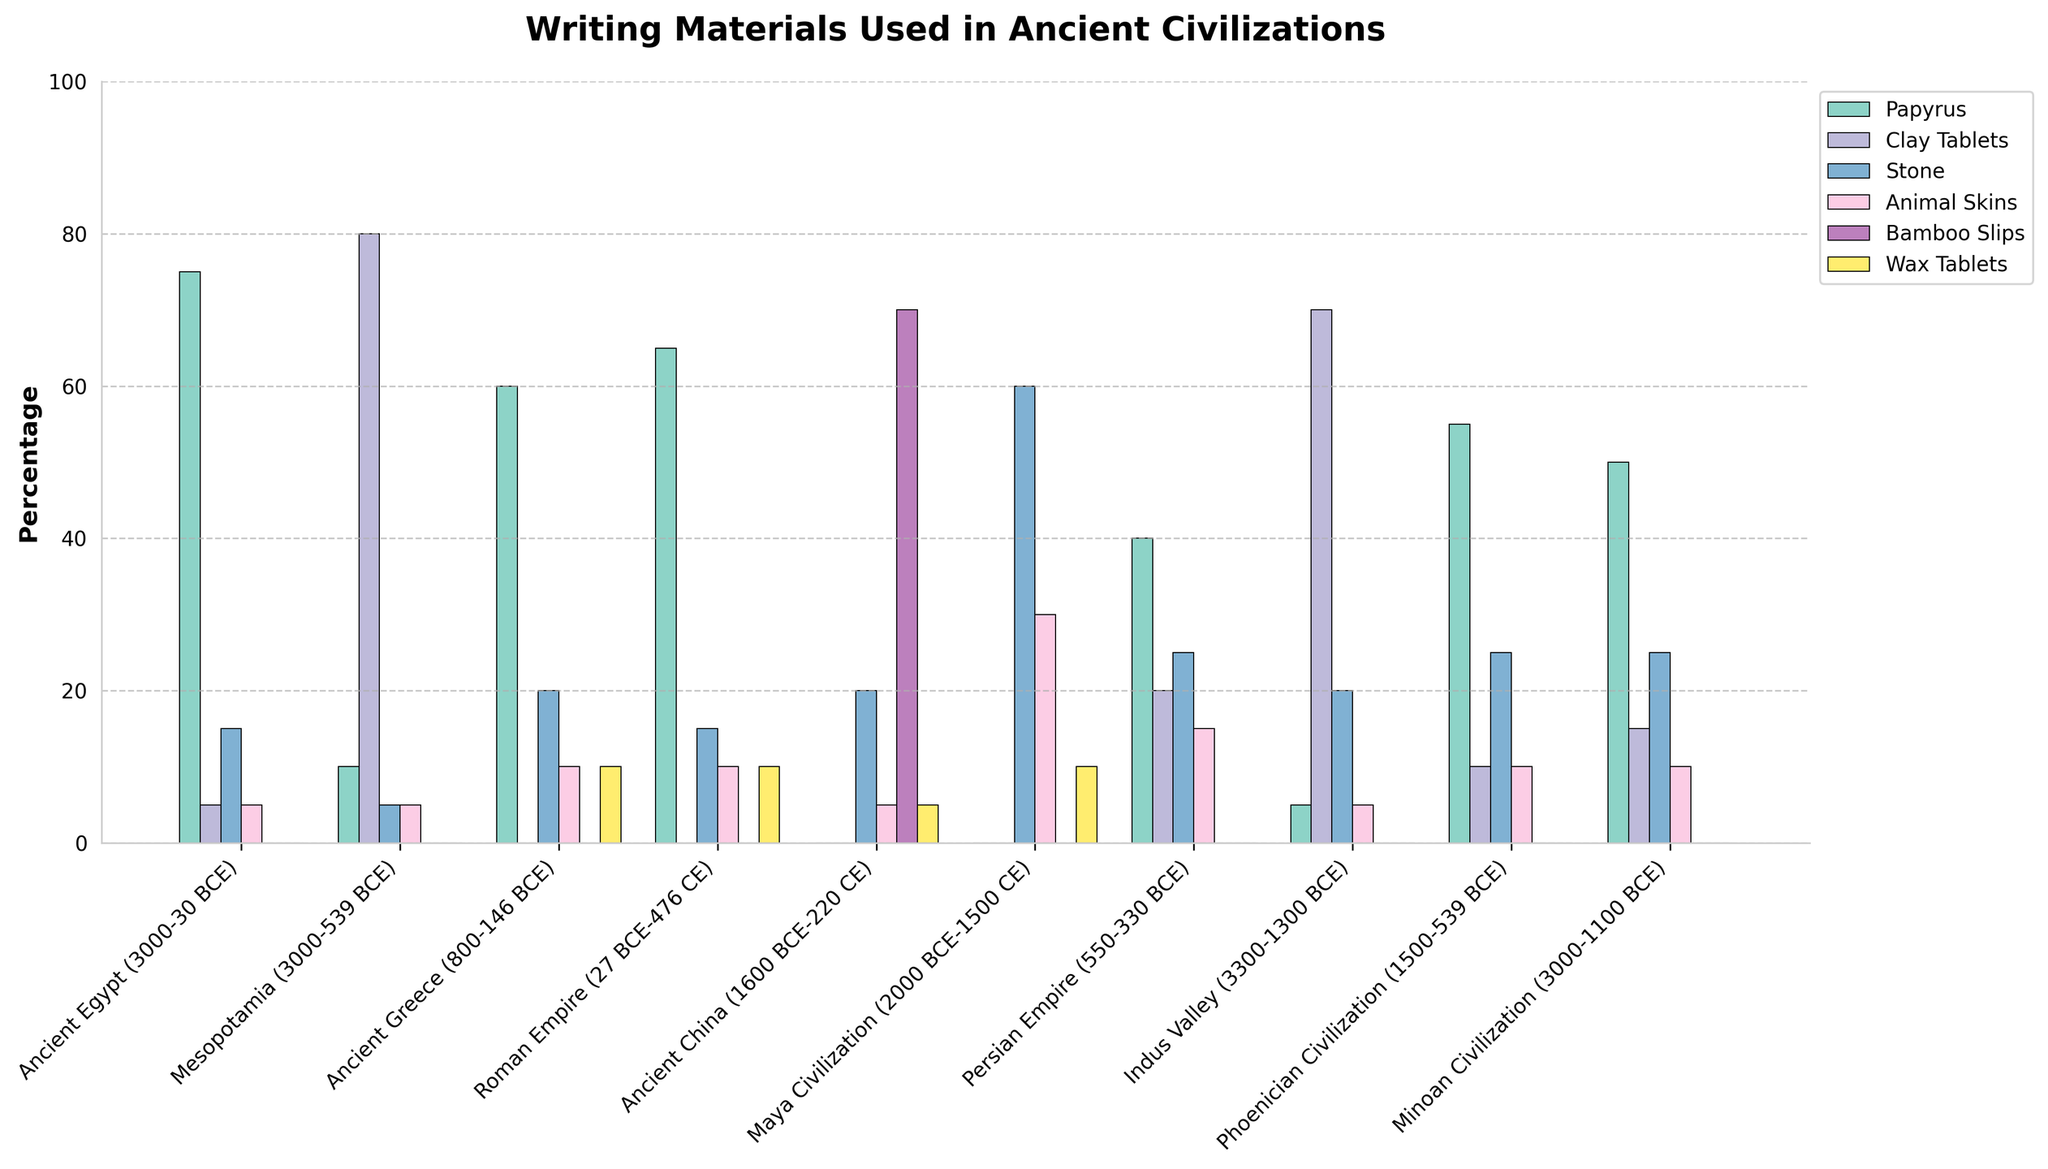Which civilization used the highest percentage of clay tablets? Compare the heights of the bars representing clay tablets across all civilizations. Mesopotamia's bar is the highest.
Answer: Mesopotamia What is the combined percentage usage of stone and animal skins in the Maya Civilization? In the Maya Civilization, the stone bar is at 60%, and the animal skins bar is at 30%. Adding these together, 60 + 30 = 90.
Answer: 90 How does the usage of papyrus in Ancient Egypt compare to that in the Roman Empire? The bar for papyrus in Ancient Egypt is at 75%, while in the Roman Empire, it is at 65%. 75% is higher than 65%.
Answer: Ancient Egypt uses more papyrus than the Roman Empire Which period had the lowest usage of bamboo slips? Except for Ancient China, all time periods have a usage of bamboo slips at 0%. Ancient China has it at 70%. Since bamboo slips are used only in Ancient China, all other periods are equally the lowest with 0%.
Answer: Ancient Egypt, Mesopotamia, Ancient Greece, Roman Empire, Maya Civilization, Persian Empire, Indus Valley, Phoenician Civilization, Minoan Civilization What is the median percentage for stone usage across all civilizations? The percentages for stone are [15, 5, 20, 15, 20, 60, 25, 20, 25, 25]. Arranging them in ascending order: [5, 15, 15, 20, 20, 25, 25, 25, 60]. The median value is the average of the middle two values (20 and 25), so (20+25)/2 = 22.5.
Answer: 22.5 Which civilization has an equal percentage usage of stone and animal skins? Looking at the figure, the Roman Empire has both stone and animal skins at 15%.
Answer: Roman Empire In which periods were wax tablets used? The bars for wax tablets are non-zero for Ancient Greece, Roman Empire, Ancient China, and Maya Civilization.
Answer: Ancient Greece, Roman Empire, Ancient China, Maya Civilization Calculate the difference in the usage of clay tablets between Mesopotamia and Indus Valley. The clay tablets usage for Mesopotamia is 80%, and for Indus Valley, it is 70%. The difference is 80 - 70 = 10.
Answer: 10 Which writing material has the most consistent usage across civilizations? The animal skins bar is uniformly shorter but present in most periods, showing small but consistent usage.
Answer: Animal Skins 